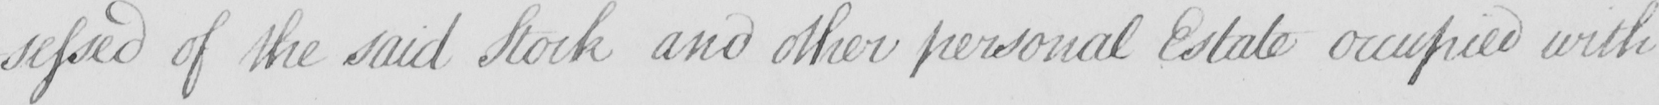What is written in this line of handwriting? -sessed of the said Stock and other personal Estate occupied with 